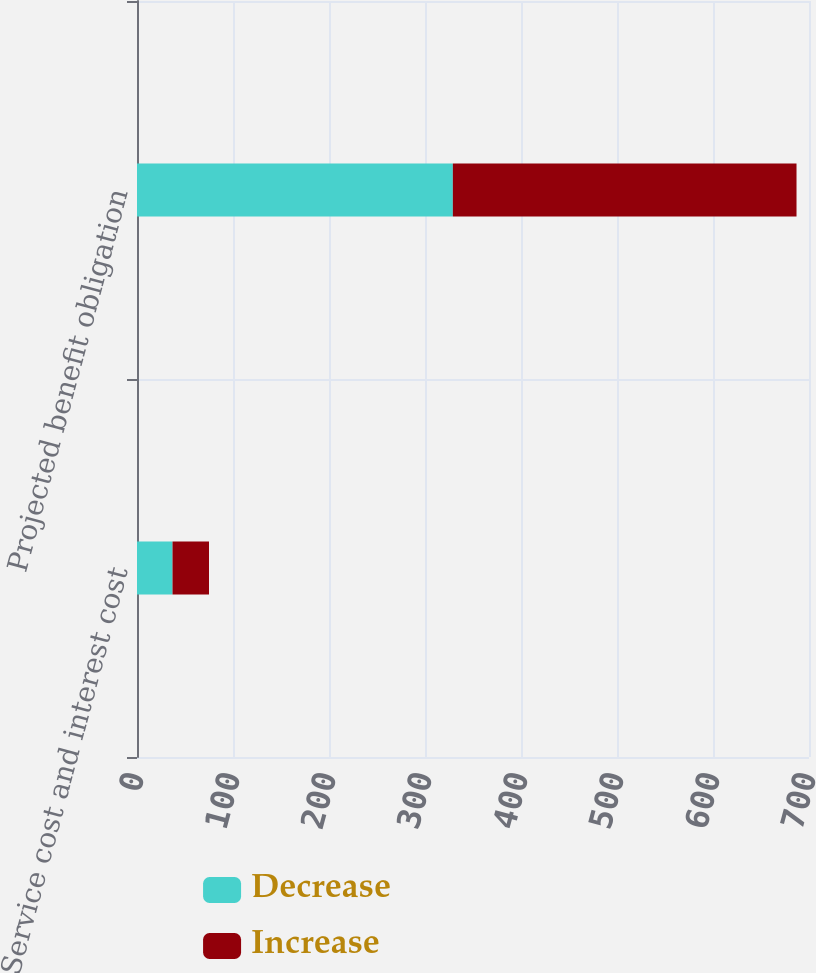Convert chart to OTSL. <chart><loc_0><loc_0><loc_500><loc_500><stacked_bar_chart><ecel><fcel>Service cost and interest cost<fcel>Projected benefit obligation<nl><fcel>Decrease<fcel>37<fcel>329<nl><fcel>Increase<fcel>38<fcel>358<nl></chart> 